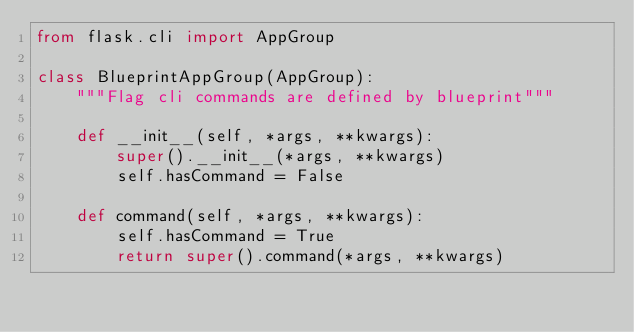<code> <loc_0><loc_0><loc_500><loc_500><_Python_>from flask.cli import AppGroup

class BlueprintAppGroup(AppGroup):
    """Flag cli commands are defined by blueprint"""

    def __init__(self, *args, **kwargs):
        super().__init__(*args, **kwargs)
        self.hasCommand = False

    def command(self, *args, **kwargs):
        self.hasCommand = True
        return super().command(*args, **kwargs)</code> 